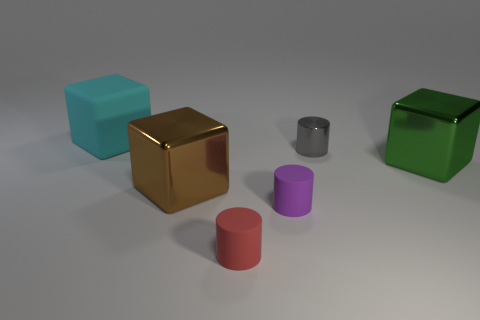Can you describe the texture and material of the objects in the image? Certainly! The objects have a smooth and polished texture, suggesting a reflective and shiny material, likely metallic or plastic. This gives each object a sleek appearance, enhancing their distinct colors. 